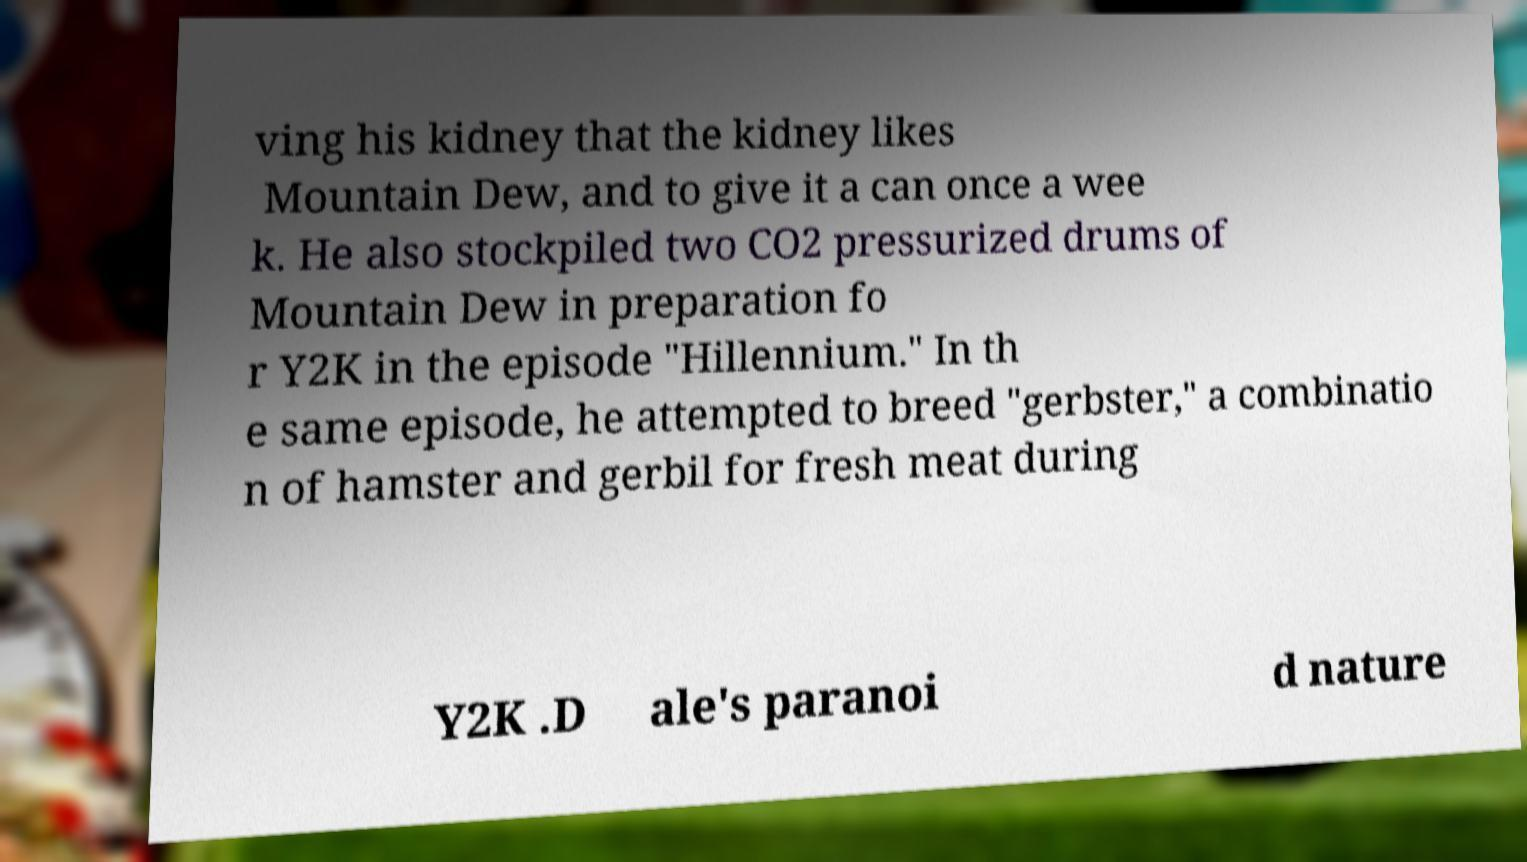Can you read and provide the text displayed in the image?This photo seems to have some interesting text. Can you extract and type it out for me? ving his kidney that the kidney likes Mountain Dew, and to give it a can once a wee k. He also stockpiled two CO2 pressurized drums of Mountain Dew in preparation fo r Y2K in the episode "Hillennium." In th e same episode, he attempted to breed "gerbster," a combinatio n of hamster and gerbil for fresh meat during Y2K .D ale's paranoi d nature 